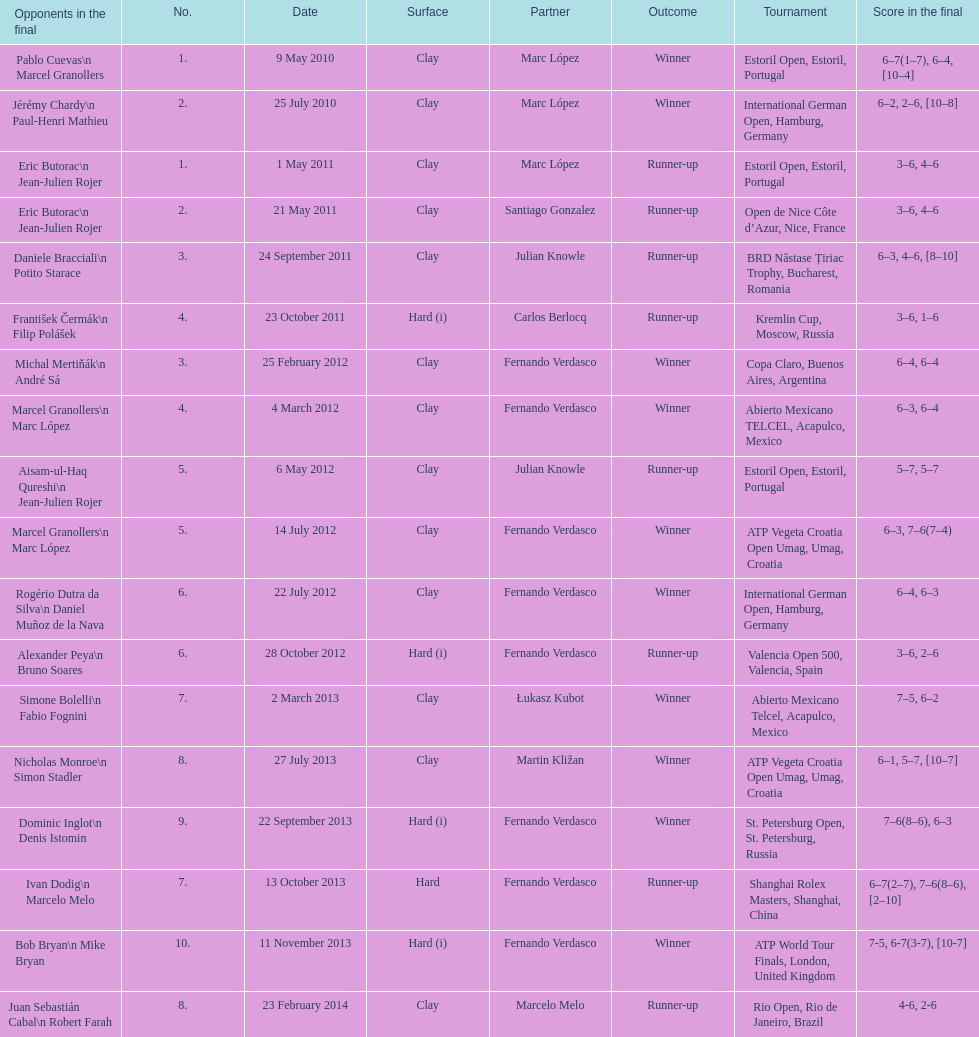Give me the full table as a dictionary. {'header': ['Opponents in the final', 'No.', 'Date', 'Surface', 'Partner', 'Outcome', 'Tournament', 'Score in the final'], 'rows': [['Pablo Cuevas\\n Marcel Granollers', '1.', '9 May 2010', 'Clay', 'Marc López', 'Winner', 'Estoril Open, Estoril, Portugal', '6–7(1–7), 6–4, [10–4]'], ['Jérémy Chardy\\n Paul-Henri Mathieu', '2.', '25 July 2010', 'Clay', 'Marc López', 'Winner', 'International German Open, Hamburg, Germany', '6–2, 2–6, [10–8]'], ['Eric Butorac\\n Jean-Julien Rojer', '1.', '1 May 2011', 'Clay', 'Marc López', 'Runner-up', 'Estoril Open, Estoril, Portugal', '3–6, 4–6'], ['Eric Butorac\\n Jean-Julien Rojer', '2.', '21 May 2011', 'Clay', 'Santiago Gonzalez', 'Runner-up', 'Open de Nice Côte d’Azur, Nice, France', '3–6, 4–6'], ['Daniele Bracciali\\n Potito Starace', '3.', '24 September 2011', 'Clay', 'Julian Knowle', 'Runner-up', 'BRD Năstase Țiriac Trophy, Bucharest, Romania', '6–3, 4–6, [8–10]'], ['František Čermák\\n Filip Polášek', '4.', '23 October 2011', 'Hard (i)', 'Carlos Berlocq', 'Runner-up', 'Kremlin Cup, Moscow, Russia', '3–6, 1–6'], ['Michal Mertiňák\\n André Sá', '3.', '25 February 2012', 'Clay', 'Fernando Verdasco', 'Winner', 'Copa Claro, Buenos Aires, Argentina', '6–4, 6–4'], ['Marcel Granollers\\n Marc López', '4.', '4 March 2012', 'Clay', 'Fernando Verdasco', 'Winner', 'Abierto Mexicano TELCEL, Acapulco, Mexico', '6–3, 6–4'], ['Aisam-ul-Haq Qureshi\\n Jean-Julien Rojer', '5.', '6 May 2012', 'Clay', 'Julian Knowle', 'Runner-up', 'Estoril Open, Estoril, Portugal', '5–7, 5–7'], ['Marcel Granollers\\n Marc López', '5.', '14 July 2012', 'Clay', 'Fernando Verdasco', 'Winner', 'ATP Vegeta Croatia Open Umag, Umag, Croatia', '6–3, 7–6(7–4)'], ['Rogério Dutra da Silva\\n Daniel Muñoz de la Nava', '6.', '22 July 2012', 'Clay', 'Fernando Verdasco', 'Winner', 'International German Open, Hamburg, Germany', '6–4, 6–3'], ['Alexander Peya\\n Bruno Soares', '6.', '28 October 2012', 'Hard (i)', 'Fernando Verdasco', 'Runner-up', 'Valencia Open 500, Valencia, Spain', '3–6, 2–6'], ['Simone Bolelli\\n Fabio Fognini', '7.', '2 March 2013', 'Clay', 'Łukasz Kubot', 'Winner', 'Abierto Mexicano Telcel, Acapulco, Mexico', '7–5, 6–2'], ['Nicholas Monroe\\n Simon Stadler', '8.', '27 July 2013', 'Clay', 'Martin Kližan', 'Winner', 'ATP Vegeta Croatia Open Umag, Umag, Croatia', '6–1, 5–7, [10–7]'], ['Dominic Inglot\\n Denis Istomin', '9.', '22 September 2013', 'Hard (i)', 'Fernando Verdasco', 'Winner', 'St. Petersburg Open, St. Petersburg, Russia', '7–6(8–6), 6–3'], ['Ivan Dodig\\n Marcelo Melo', '7.', '13 October 2013', 'Hard', 'Fernando Verdasco', 'Runner-up', 'Shanghai Rolex Masters, Shanghai, China', '6–7(2–7), 7–6(8–6), [2–10]'], ['Bob Bryan\\n Mike Bryan', '10.', '11 November 2013', 'Hard (i)', 'Fernando Verdasco', 'Winner', 'ATP World Tour Finals, London, United Kingdom', '7-5, 6-7(3-7), [10-7]'], ['Juan Sebastián Cabal\\n Robert Farah', '8.', '23 February 2014', 'Clay', 'Marcelo Melo', 'Runner-up', 'Rio Open, Rio de Janeiro, Brazil', '4-6, 2-6']]} Which tournament has the largest number? ATP World Tour Finals. 